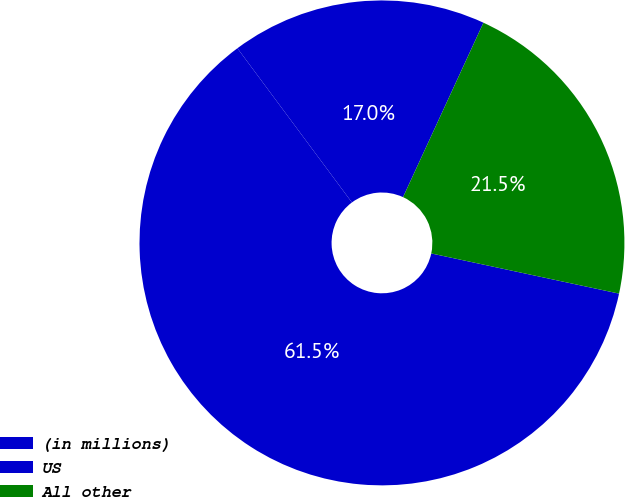Convert chart to OTSL. <chart><loc_0><loc_0><loc_500><loc_500><pie_chart><fcel>(in millions)<fcel>US<fcel>All other<nl><fcel>17.04%<fcel>61.48%<fcel>21.48%<nl></chart> 